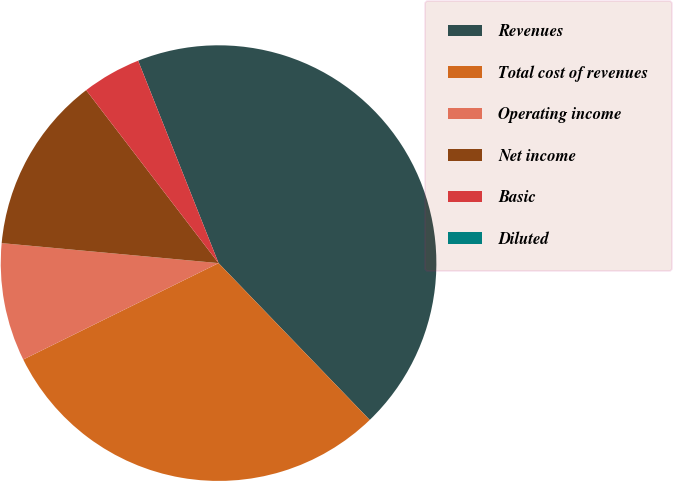Convert chart to OTSL. <chart><loc_0><loc_0><loc_500><loc_500><pie_chart><fcel>Revenues<fcel>Total cost of revenues<fcel>Operating income<fcel>Net income<fcel>Basic<fcel>Diluted<nl><fcel>43.81%<fcel>29.91%<fcel>8.76%<fcel>13.14%<fcel>4.38%<fcel>0.0%<nl></chart> 